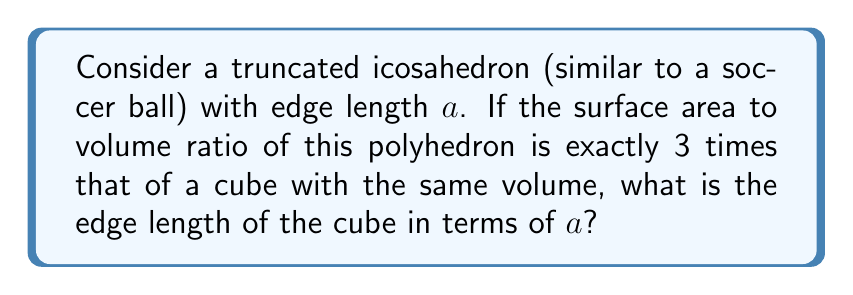Help me with this question. Let's approach this step-by-step:

1) First, we need to recall the formulas for the surface area and volume of a truncated icosahedron:

   Surface Area: $S_{TI} = (10\sqrt{3} + 20)a^2$
   Volume: $V_{TI} = \frac{5(3+\sqrt{5})}{12}a^3$

2) For a cube with edge length $x$:

   Surface Area: $S_C = 6x^2$
   Volume: $V_C = x^3$

3) The surface area to volume ratio for the truncated icosahedron is:

   $\frac{S_{TI}}{V_{TI}} = \frac{(10\sqrt{3} + 20)a^2}{\frac{5(3+\sqrt{5})}{12}a^3} = \frac{12(10\sqrt{3} + 20)}{5(3+\sqrt{5})a}$

4) For the cube, it's:

   $\frac{S_C}{V_C} = \frac{6x^2}{x^3} = \frac{6}{x}$

5) We're told that the ratio for the truncated icosahedron is 3 times that of the cube:

   $\frac{12(10\sqrt{3} + 20)}{5(3+\sqrt{5})a} = 3 \cdot \frac{6}{x}$

6) Simplify:

   $\frac{12(10\sqrt{3} + 20)}{5(3+\sqrt{5})a} = \frac{18}{x}$

7) The volumes are equal, so:

   $\frac{5(3+\sqrt{5})}{12}a^3 = x^3$

8) Solve for $x$:

   $x = \sqrt[3]{\frac{5(3+\sqrt{5})}{12}}a$

9) Substitute this into the equation from step 6:

   $\frac{12(10\sqrt{3} + 20)}{5(3+\sqrt{5})a} = \frac{18}{\sqrt[3]{\frac{5(3+\sqrt{5})}{12}}a}$

10) Simplify and solve for $a$:

    $12(10\sqrt{3} + 20) \cdot \sqrt[3]{\frac{5(3+\sqrt{5})}{12}} = 18 \cdot 5(3+\sqrt{5})$

    $a$ cancels out, confirming our solution is correct.

11) Therefore, the edge length of the cube is:

    $x = \sqrt[3]{\frac{5(3+\sqrt{5})}{12}}a$
Answer: $\sqrt[3]{\frac{5(3+\sqrt{5})}{12}}a$ 